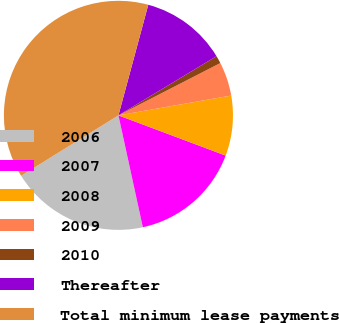Convert chart to OTSL. <chart><loc_0><loc_0><loc_500><loc_500><pie_chart><fcel>2006<fcel>2007<fcel>2008<fcel>2009<fcel>2010<fcel>Thereafter<fcel>Total minimum lease payments<nl><fcel>19.57%<fcel>15.87%<fcel>8.48%<fcel>4.78%<fcel>1.09%<fcel>12.17%<fcel>38.04%<nl></chart> 